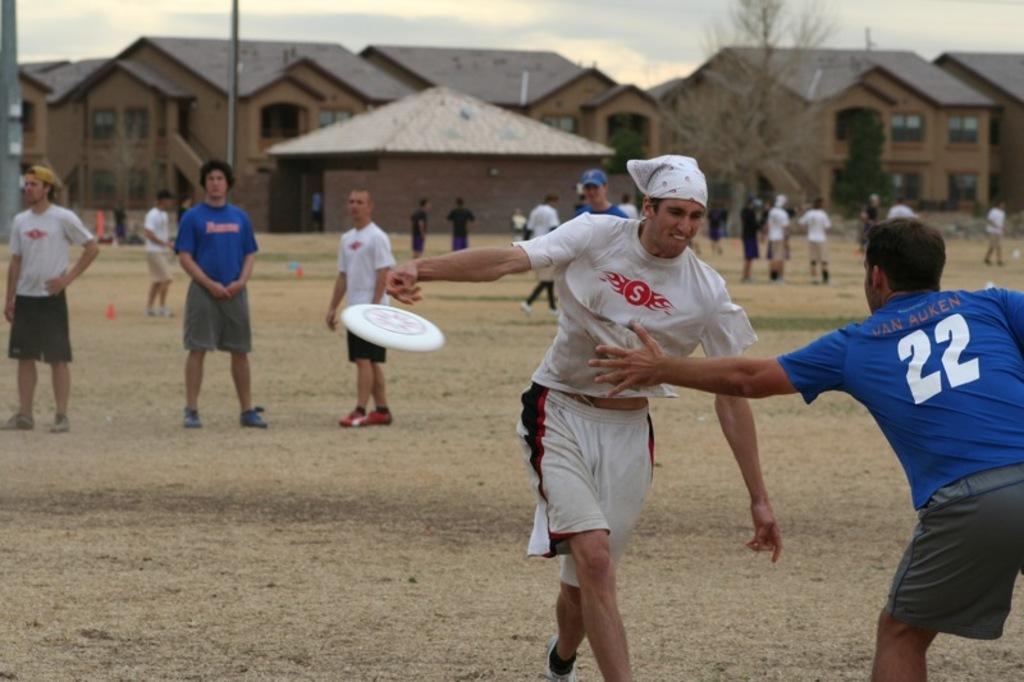How many people are in the image? There are people in the image, but the exact number is not specified. What is happening with the Frisbee in the image? A Frisbee is in the air in the image. What can be seen on the ground in the image? The ground is visible in the image. What structures can be seen in the background of the image? There are buildings, a house, a tree, and poles in the background of the image. What is visible in the sky in the image? The sky is visible in the background of the image. Can you tell me which actor is holding the yam in the image? There is no actor or yam present in the image. 